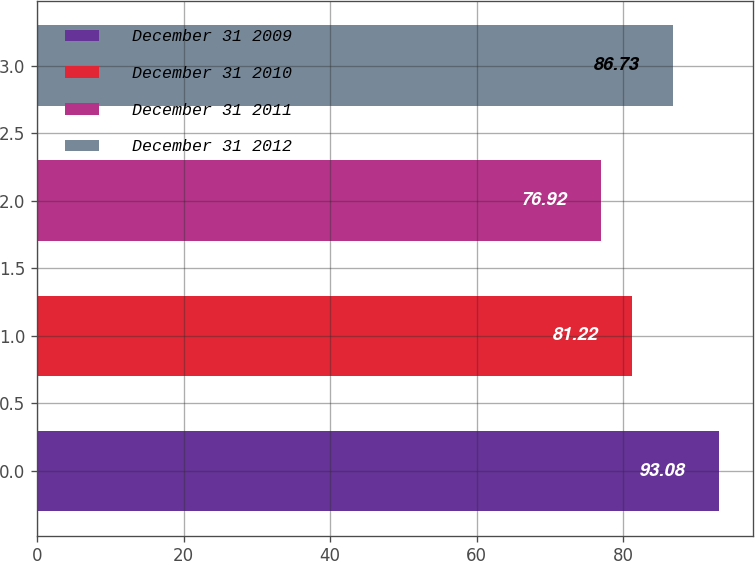Convert chart. <chart><loc_0><loc_0><loc_500><loc_500><bar_chart><fcel>December 31 2009<fcel>December 31 2010<fcel>December 31 2011<fcel>December 31 2012<nl><fcel>93.08<fcel>81.22<fcel>76.92<fcel>86.73<nl></chart> 